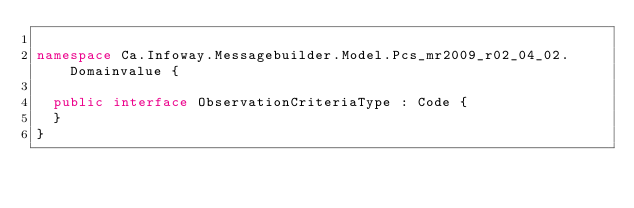<code> <loc_0><loc_0><loc_500><loc_500><_C#_>
namespace Ca.Infoway.Messagebuilder.Model.Pcs_mr2009_r02_04_02.Domainvalue {

  public interface ObservationCriteriaType : Code {
  }
}
</code> 